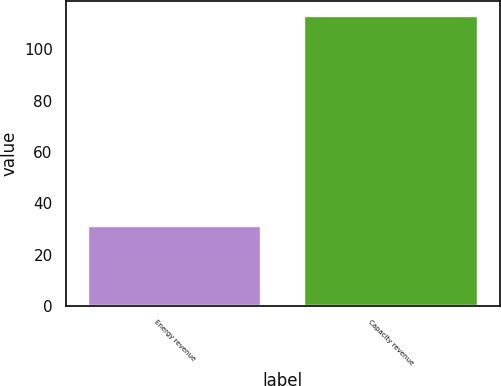Convert chart. <chart><loc_0><loc_0><loc_500><loc_500><bar_chart><fcel>Energy revenue<fcel>Capacity revenue<nl><fcel>31<fcel>113<nl></chart> 